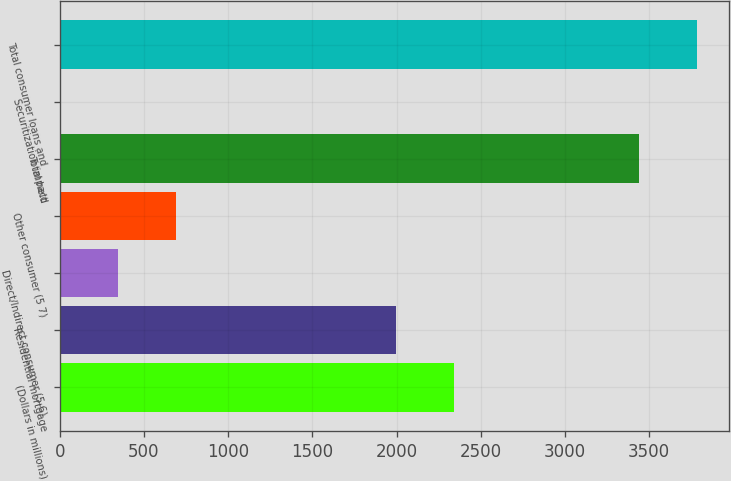Convert chart to OTSL. <chart><loc_0><loc_0><loc_500><loc_500><bar_chart><fcel>(Dollars in millions)<fcel>Residential mortgage<fcel>Direct/Indirect consumer (5 6)<fcel>Other consumer (5 7)<fcel>Total held<fcel>Securitization impact<fcel>Total consumer loans and<nl><fcel>2343.2<fcel>1999<fcel>346.2<fcel>690.4<fcel>3442<fcel>2<fcel>3786.2<nl></chart> 